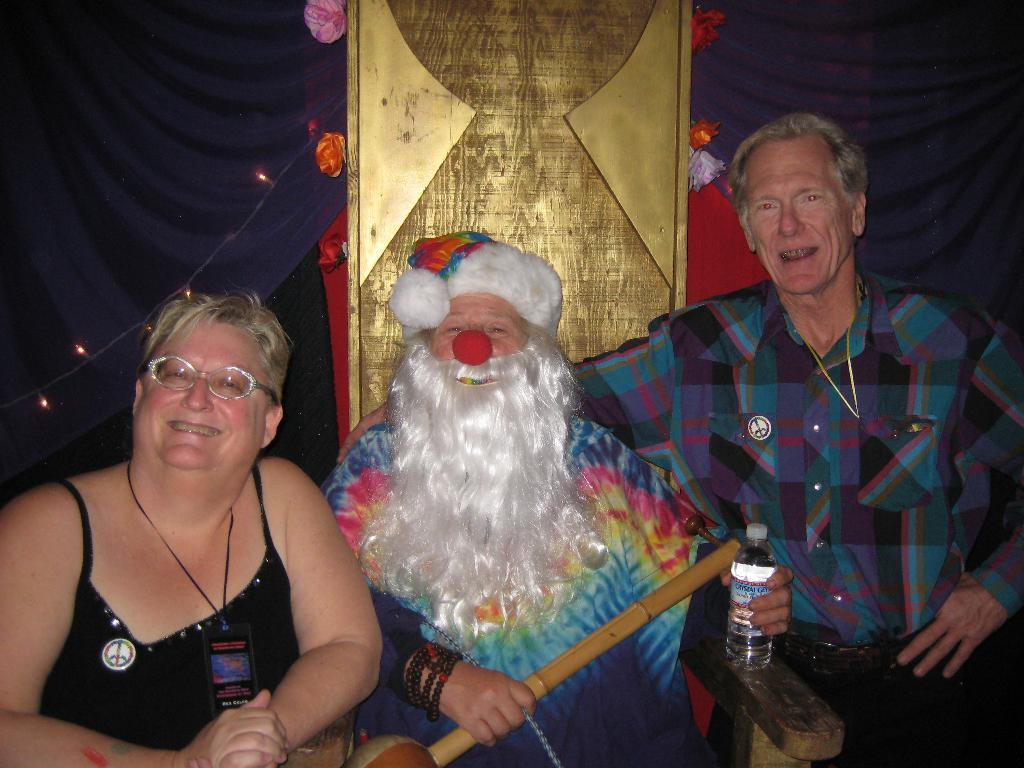What is the person in the image holding? The person is holding a bottle in the image. What are the other people in the image doing? There are people sitting on chairs in the image. What else can be seen in the image besides the people and the bottle? There is a cable with lights in the image. What letters are visible on the brain in the image? There is no brain or letters present in the image. 